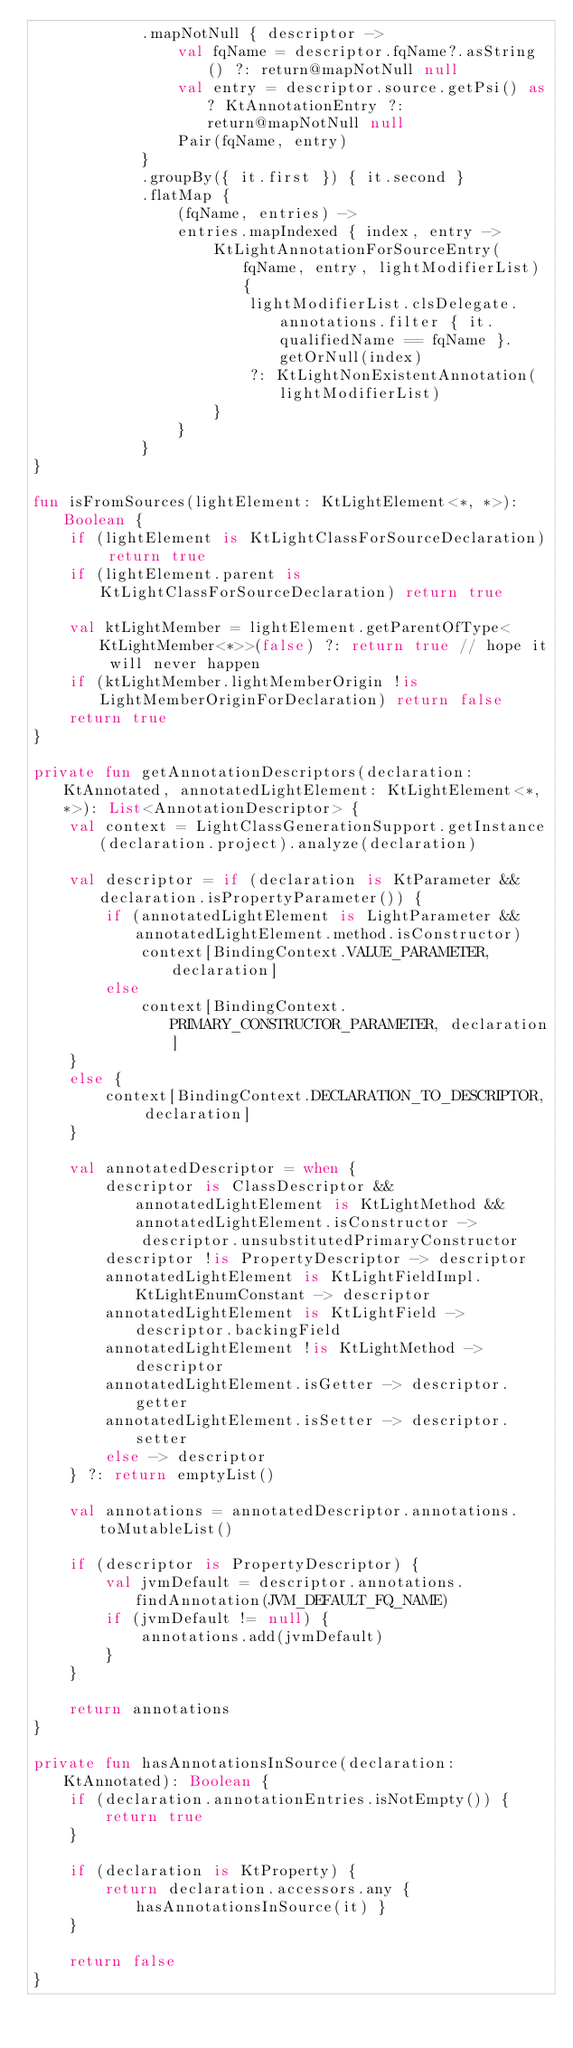<code> <loc_0><loc_0><loc_500><loc_500><_Kotlin_>            .mapNotNull { descriptor ->
                val fqName = descriptor.fqName?.asString() ?: return@mapNotNull null
                val entry = descriptor.source.getPsi() as? KtAnnotationEntry ?: return@mapNotNull null
                Pair(fqName, entry)
            }
            .groupBy({ it.first }) { it.second }
            .flatMap {
                (fqName, entries) ->
                entries.mapIndexed { index, entry ->
                    KtLightAnnotationForSourceEntry(fqName, entry, lightModifierList) {
                        lightModifierList.clsDelegate.annotations.filter { it.qualifiedName == fqName }.getOrNull(index)
                        ?: KtLightNonExistentAnnotation(lightModifierList)
                    }
                }
            }
}

fun isFromSources(lightElement: KtLightElement<*, *>): Boolean {
    if (lightElement is KtLightClassForSourceDeclaration) return true
    if (lightElement.parent is KtLightClassForSourceDeclaration) return true

    val ktLightMember = lightElement.getParentOfType<KtLightMember<*>>(false) ?: return true // hope it will never happen
    if (ktLightMember.lightMemberOrigin !is LightMemberOriginForDeclaration) return false
    return true
}

private fun getAnnotationDescriptors(declaration: KtAnnotated, annotatedLightElement: KtLightElement<*, *>): List<AnnotationDescriptor> {
    val context = LightClassGenerationSupport.getInstance(declaration.project).analyze(declaration)

    val descriptor = if (declaration is KtParameter && declaration.isPropertyParameter()) {
        if (annotatedLightElement is LightParameter && annotatedLightElement.method.isConstructor)
            context[BindingContext.VALUE_PARAMETER, declaration]
        else
            context[BindingContext.PRIMARY_CONSTRUCTOR_PARAMETER, declaration]
    }
    else {
        context[BindingContext.DECLARATION_TO_DESCRIPTOR, declaration]
    }

    val annotatedDescriptor = when {
        descriptor is ClassDescriptor && annotatedLightElement is KtLightMethod && annotatedLightElement.isConstructor ->
            descriptor.unsubstitutedPrimaryConstructor
        descriptor !is PropertyDescriptor -> descriptor
        annotatedLightElement is KtLightFieldImpl.KtLightEnumConstant -> descriptor
        annotatedLightElement is KtLightField -> descriptor.backingField
        annotatedLightElement !is KtLightMethod -> descriptor
        annotatedLightElement.isGetter -> descriptor.getter
        annotatedLightElement.isSetter -> descriptor.setter
        else -> descriptor
    } ?: return emptyList()

    val annotations = annotatedDescriptor.annotations.toMutableList()

    if (descriptor is PropertyDescriptor) {
        val jvmDefault = descriptor.annotations.findAnnotation(JVM_DEFAULT_FQ_NAME)
        if (jvmDefault != null) {
            annotations.add(jvmDefault)
        }
    }

    return annotations
}

private fun hasAnnotationsInSource(declaration: KtAnnotated): Boolean {
    if (declaration.annotationEntries.isNotEmpty()) {
        return true
    }

    if (declaration is KtProperty) {
        return declaration.accessors.any { hasAnnotationsInSource(it) }
    }

    return false
}

</code> 